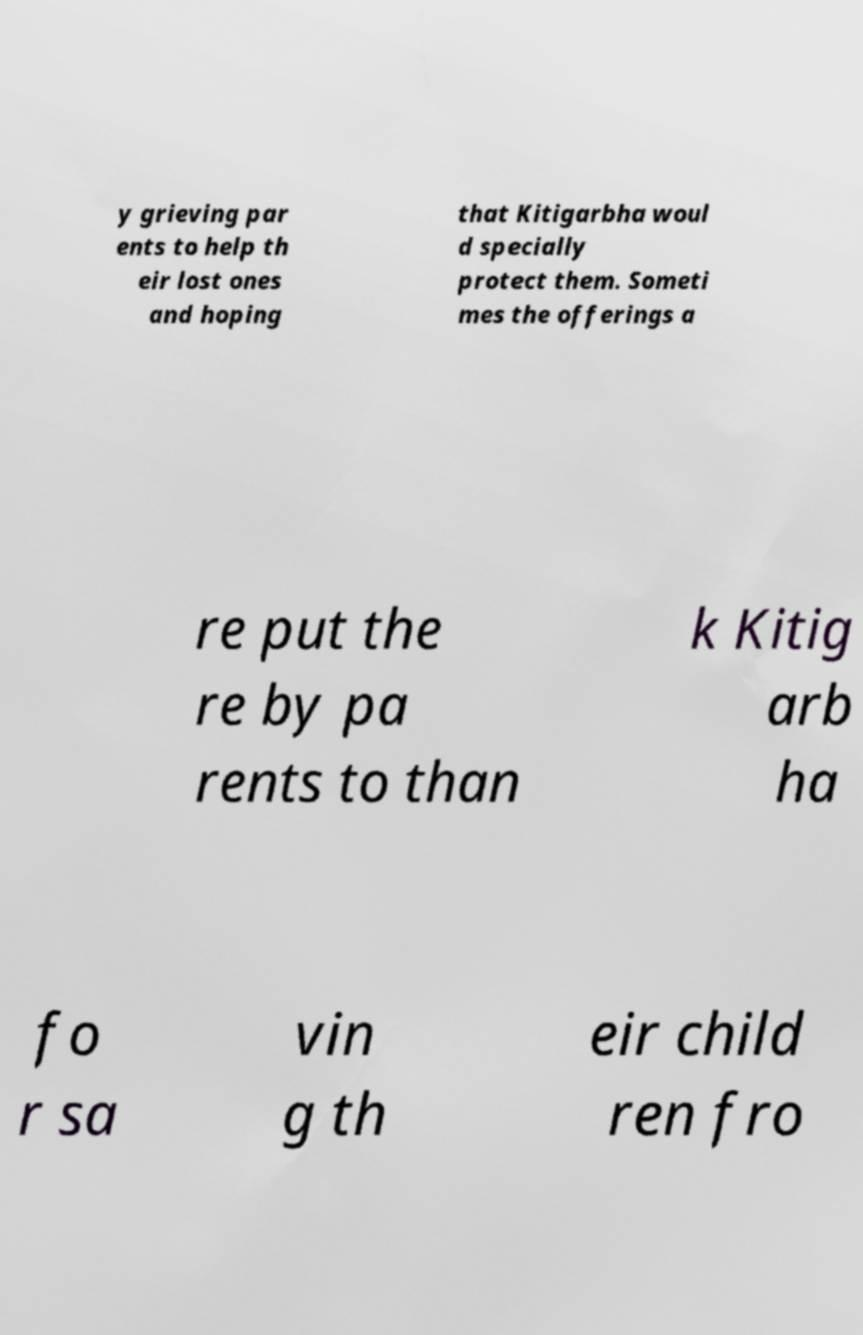What messages or text are displayed in this image? I need them in a readable, typed format. y grieving par ents to help th eir lost ones and hoping that Kitigarbha woul d specially protect them. Someti mes the offerings a re put the re by pa rents to than k Kitig arb ha fo r sa vin g th eir child ren fro 